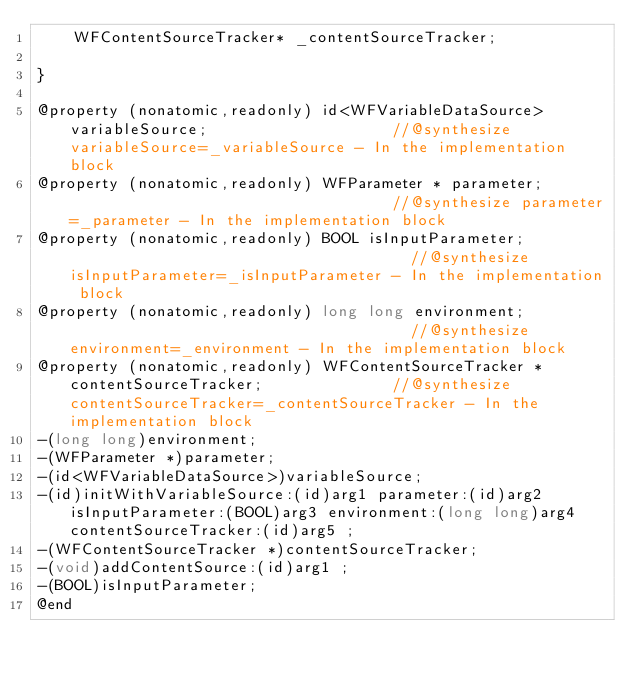Convert code to text. <code><loc_0><loc_0><loc_500><loc_500><_C_>	WFContentSourceTracker* _contentSourceTracker;

}

@property (nonatomic,readonly) id<WFVariableDataSource> variableSource;                    //@synthesize variableSource=_variableSource - In the implementation block
@property (nonatomic,readonly) WFParameter * parameter;                                    //@synthesize parameter=_parameter - In the implementation block
@property (nonatomic,readonly) BOOL isInputParameter;                                      //@synthesize isInputParameter=_isInputParameter - In the implementation block
@property (nonatomic,readonly) long long environment;                                      //@synthesize environment=_environment - In the implementation block
@property (nonatomic,readonly) WFContentSourceTracker * contentSourceTracker;              //@synthesize contentSourceTracker=_contentSourceTracker - In the implementation block
-(long long)environment;
-(WFParameter *)parameter;
-(id<WFVariableDataSource>)variableSource;
-(id)initWithVariableSource:(id)arg1 parameter:(id)arg2 isInputParameter:(BOOL)arg3 environment:(long long)arg4 contentSourceTracker:(id)arg5 ;
-(WFContentSourceTracker *)contentSourceTracker;
-(void)addContentSource:(id)arg1 ;
-(BOOL)isInputParameter;
@end

</code> 